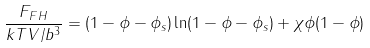<formula> <loc_0><loc_0><loc_500><loc_500>\frac { F _ { F H } } { k T V / b ^ { 3 } } = ( 1 - \phi - \phi _ { s } ) \ln ( 1 - \phi - \phi _ { s } ) + \chi \phi ( 1 - \phi )</formula> 